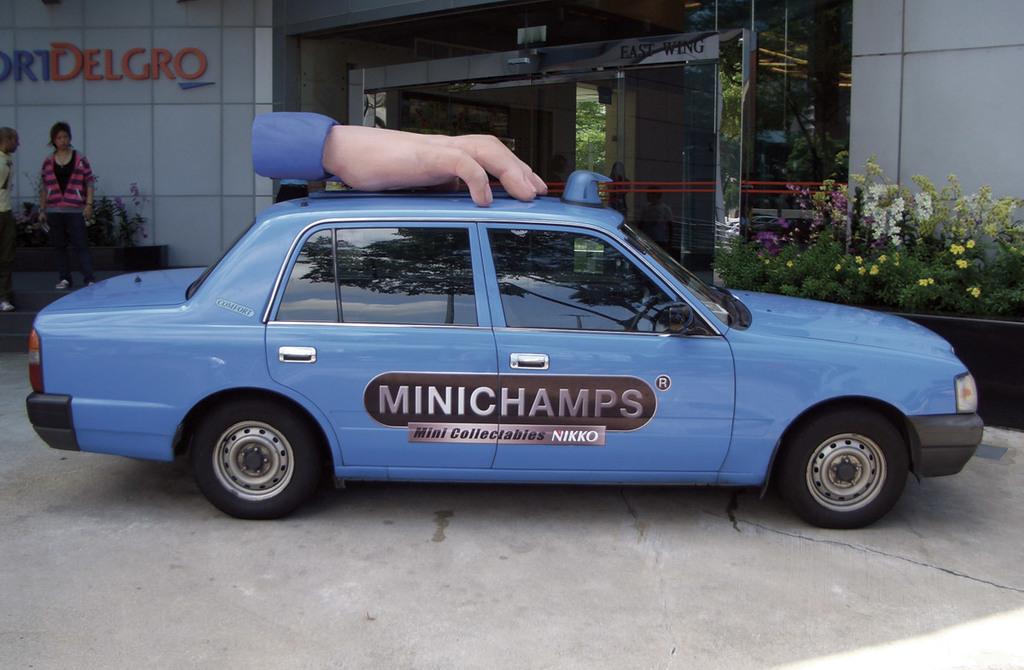What name is on this car?
Provide a short and direct response. Minichamps. What is on the wall behind the car?
Offer a terse response. Delgro. 